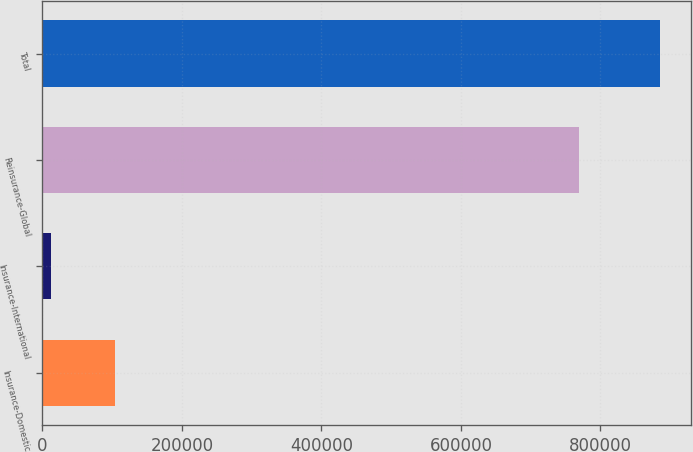Convert chart to OTSL. <chart><loc_0><loc_0><loc_500><loc_500><bar_chart><fcel>Insurance-Domestic<fcel>Insurance-International<fcel>Reinsurance-Global<fcel>Total<nl><fcel>104407<fcel>11749<fcel>768763<fcel>884919<nl></chart> 